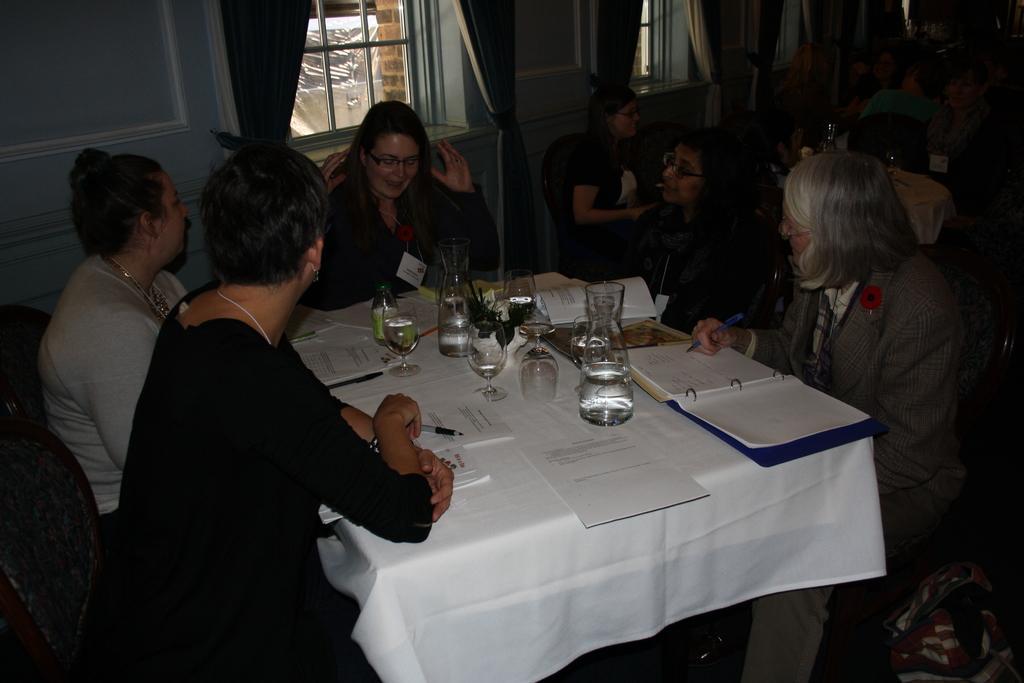Can you describe this image briefly? In this image i can see a group of people are sitting on a chair in front of a table. On the table we have few glasses and other objects on it. 